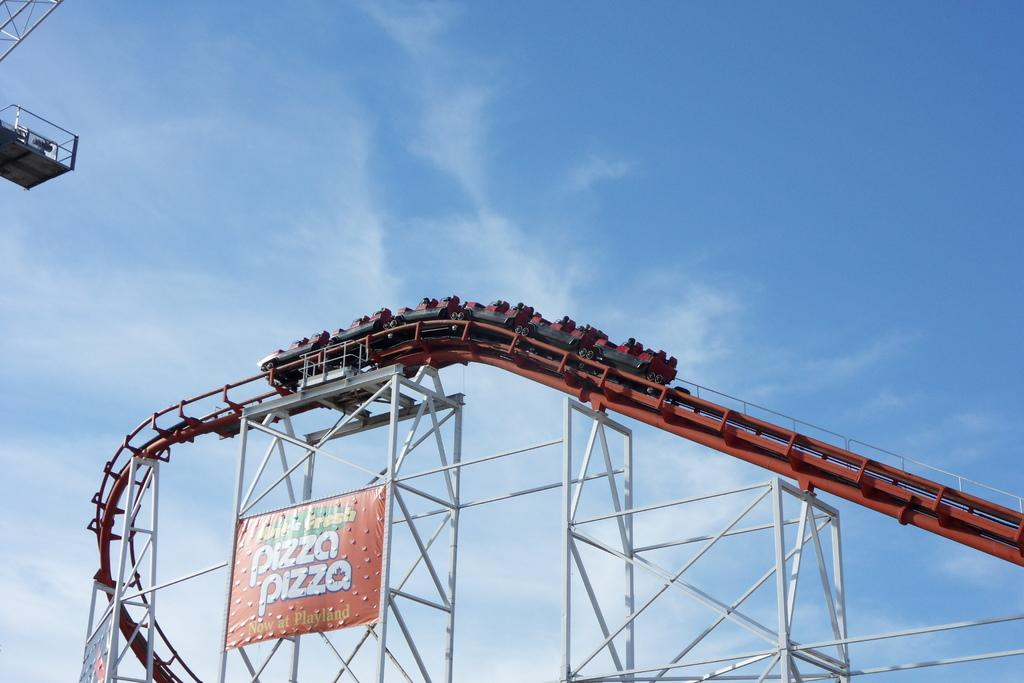<image>
Create a compact narrative representing the image presented. A rollercoaster rides by an advertisement that says "Pizza Pizza now at Playland." 